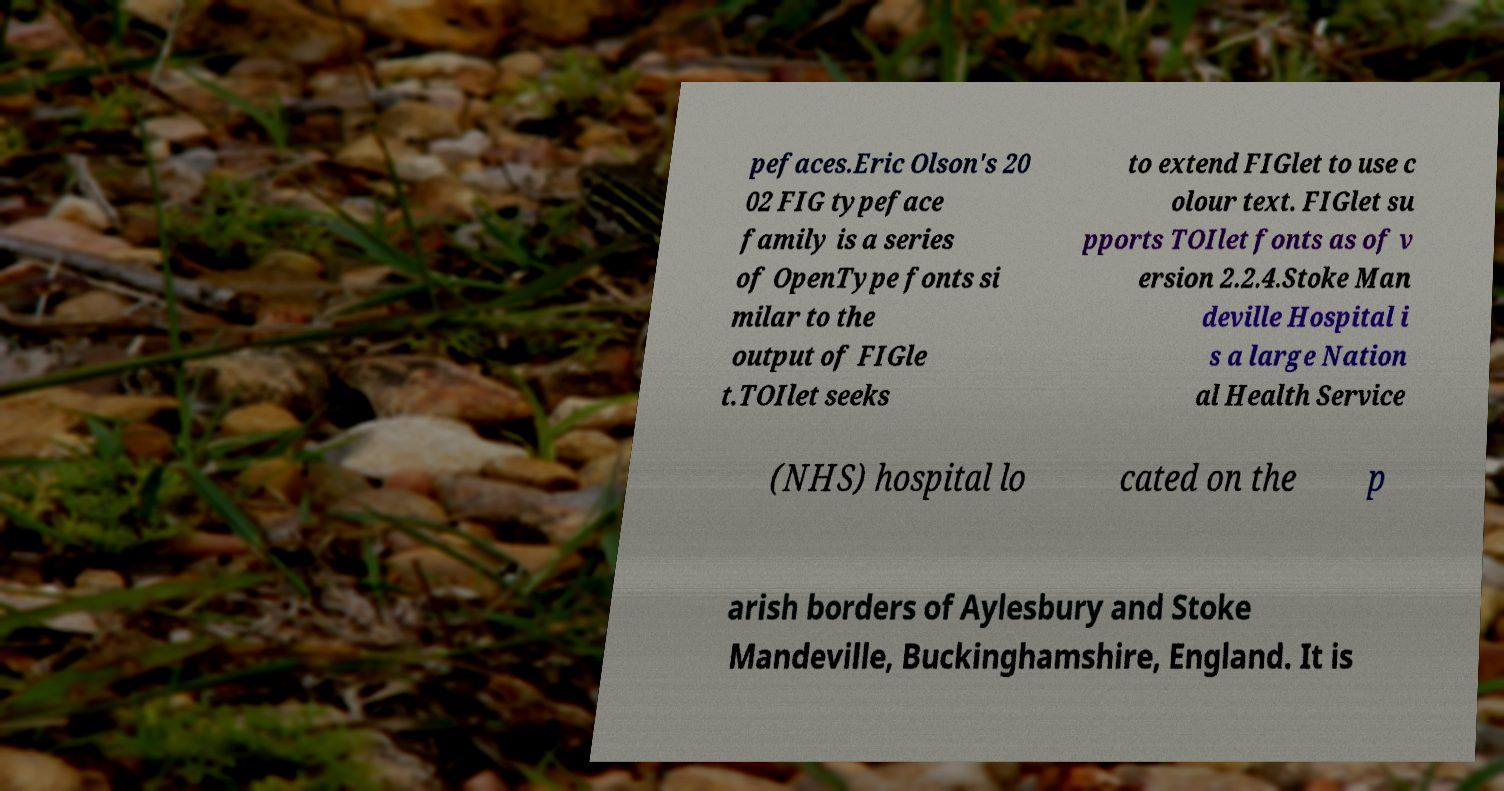Could you assist in decoding the text presented in this image and type it out clearly? pefaces.Eric Olson's 20 02 FIG typeface family is a series of OpenType fonts si milar to the output of FIGle t.TOIlet seeks to extend FIGlet to use c olour text. FIGlet su pports TOIlet fonts as of v ersion 2.2.4.Stoke Man deville Hospital i s a large Nation al Health Service (NHS) hospital lo cated on the p arish borders of Aylesbury and Stoke Mandeville, Buckinghamshire, England. It is 